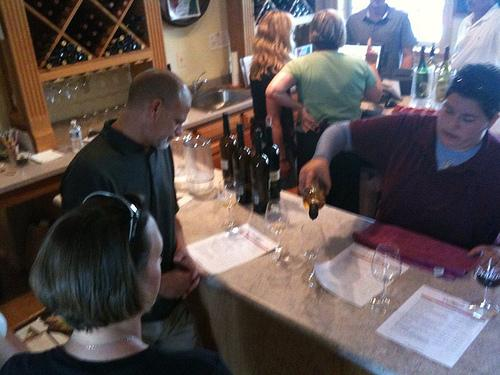What kind of wine is the man serving in the glasses?

Choices:
A) red
B) orange
C) pink
D) white white 